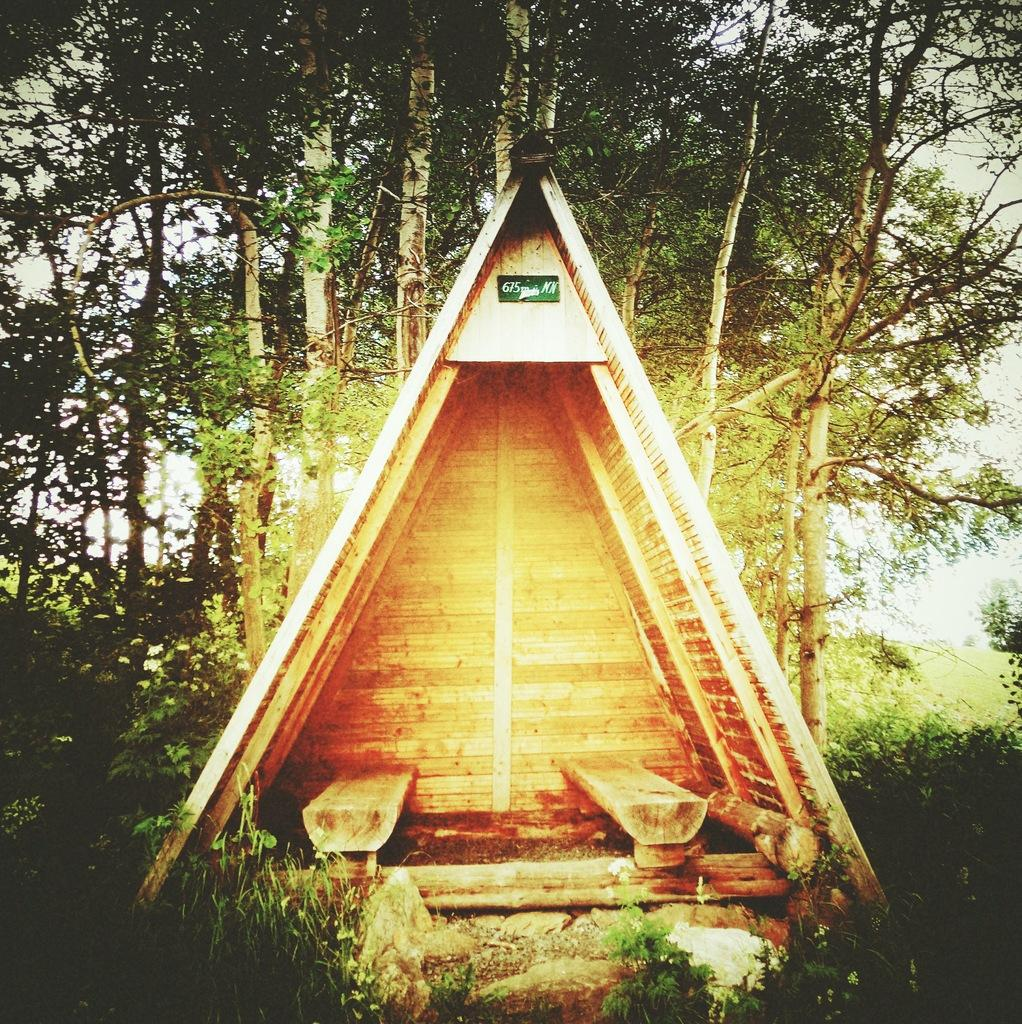What type of structure is in the picture? There is a wooden cabin in the picture. What else can be seen in the picture besides the cabin? There are plants in the picture. What is visible in the background of the picture? There are trees in the background of the picture. What type of lace can be seen on the scarecrow in the picture? There is no scarecrow present in the picture, so there is no lace to be seen. 